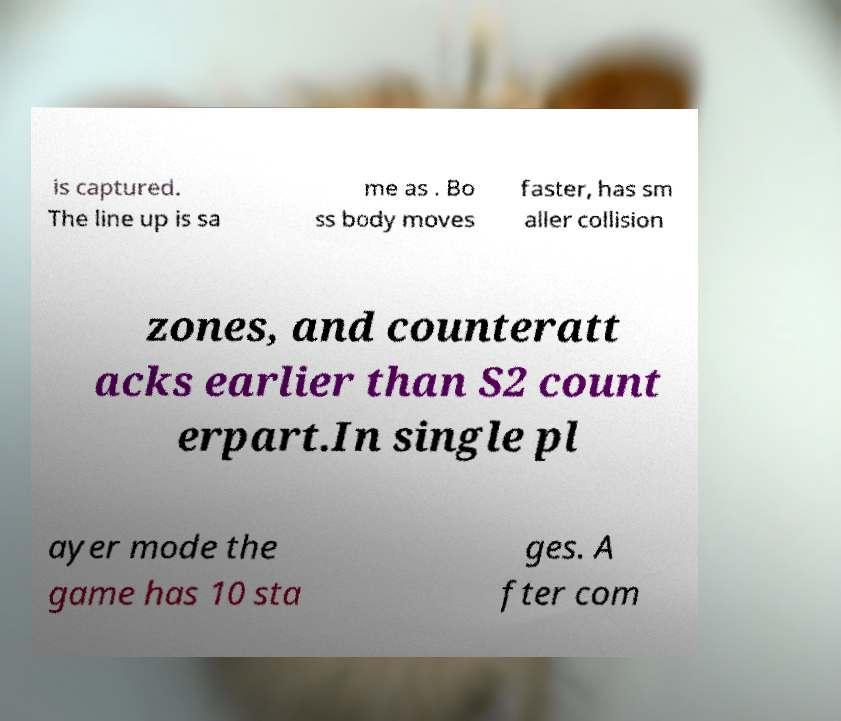Could you assist in decoding the text presented in this image and type it out clearly? is captured. The line up is sa me as . Bo ss body moves faster, has sm aller collision zones, and counteratt acks earlier than S2 count erpart.In single pl ayer mode the game has 10 sta ges. A fter com 